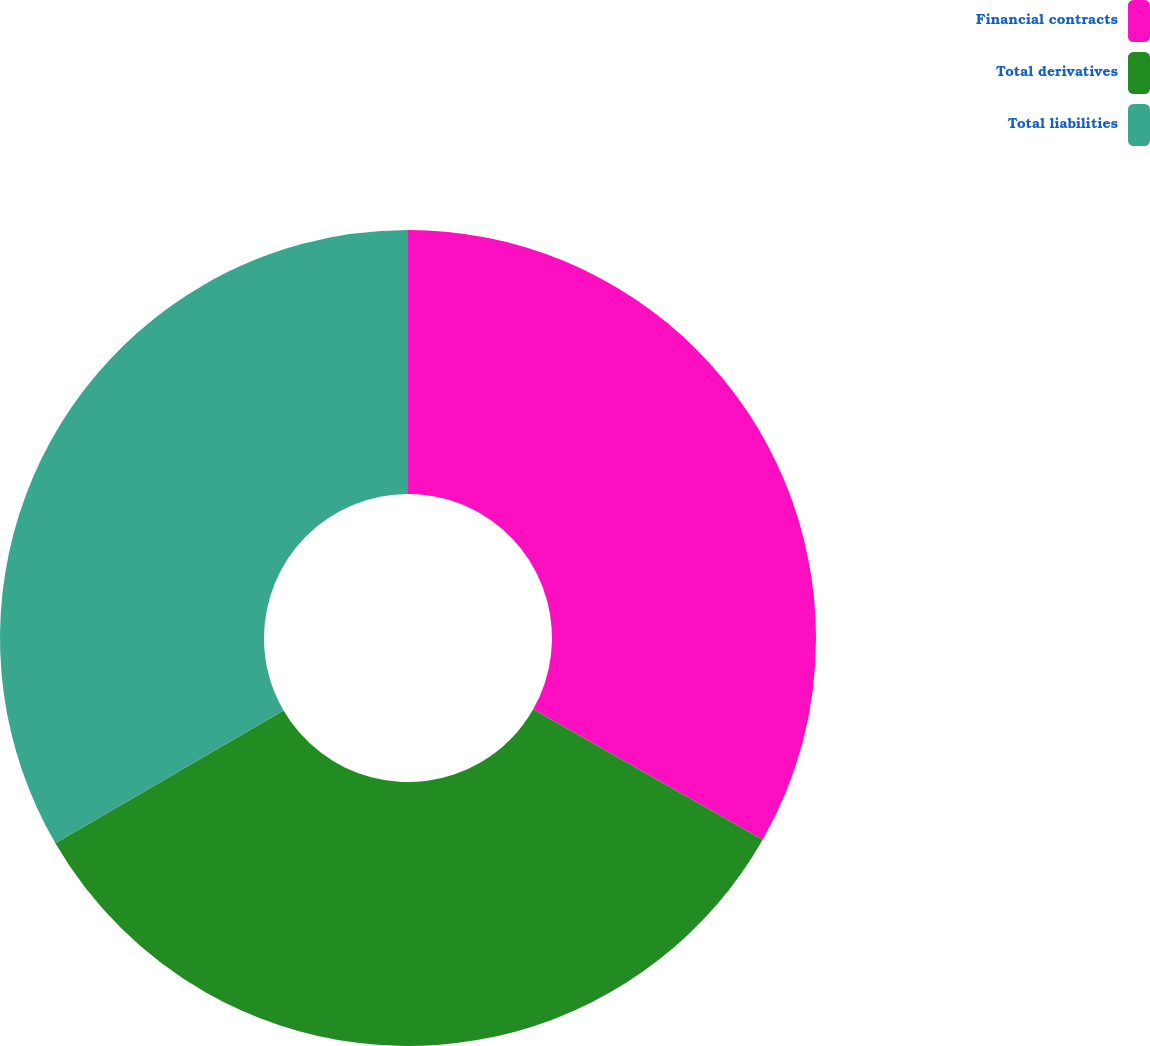Convert chart to OTSL. <chart><loc_0><loc_0><loc_500><loc_500><pie_chart><fcel>Financial contracts<fcel>Total derivatives<fcel>Total liabilities<nl><fcel>33.23%<fcel>33.38%<fcel>33.39%<nl></chart> 